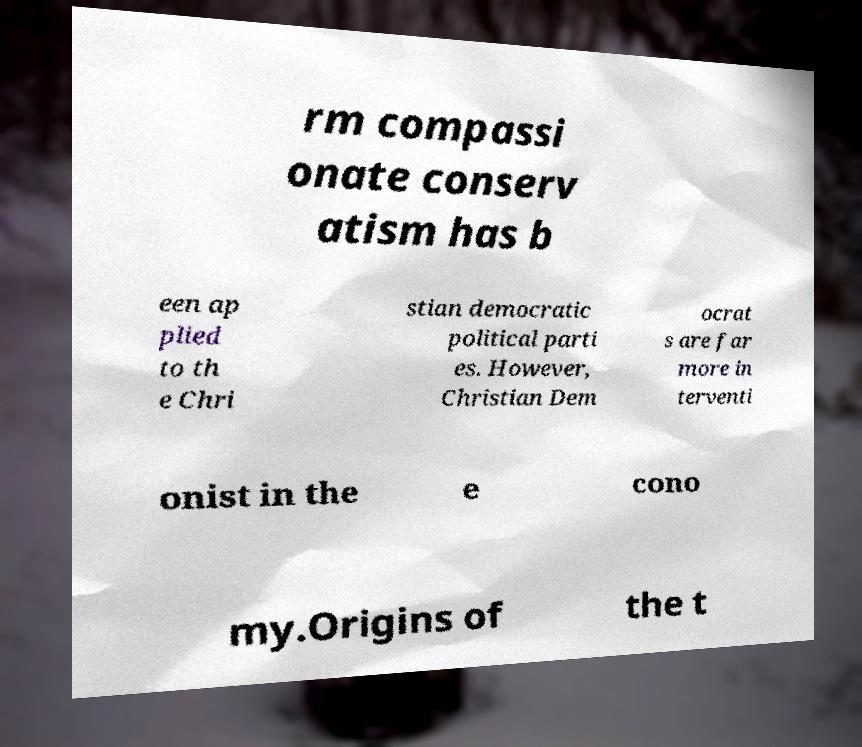Can you read and provide the text displayed in the image?This photo seems to have some interesting text. Can you extract and type it out for me? rm compassi onate conserv atism has b een ap plied to th e Chri stian democratic political parti es. However, Christian Dem ocrat s are far more in terventi onist in the e cono my.Origins of the t 